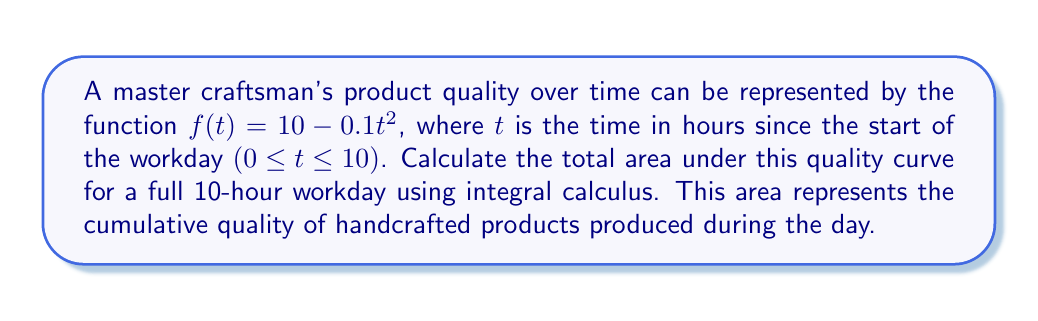Can you answer this question? To calculate the area under the curve, we need to integrate the function $f(t) = 10 - 0.1t^2$ from $t=0$ to $t=10$.

Step 1: Set up the definite integral
$$\int_0^{10} (10 - 0.1t^2) \, dt$$

Step 2: Integrate the function
$$\int (10 - 0.1t^2) \, dt = 10t - \frac{0.1t^3}{3} + C$$

Step 3: Apply the limits of integration
$$\left[10t - \frac{0.1t^3}{3}\right]_0^{10}$$

Step 4: Evaluate the integral
$$(10 \cdot 10 - \frac{0.1 \cdot 10^3}{3}) - (10 \cdot 0 - \frac{0.1 \cdot 0^3}{3})$$
$$= (100 - \frac{100}{3}) - 0$$
$$= 100 - \frac{100}{3}$$
$$= \frac{300}{3} - \frac{100}{3} = \frac{200}{3}$$

Step 5: Simplify the result
$$\frac{200}{3} \approx 66.67$$

The area under the curve, representing the cumulative quality of handcrafted products over a 10-hour workday, is approximately 66.67 quality-hours.
Answer: $\frac{200}{3}$ quality-hours 